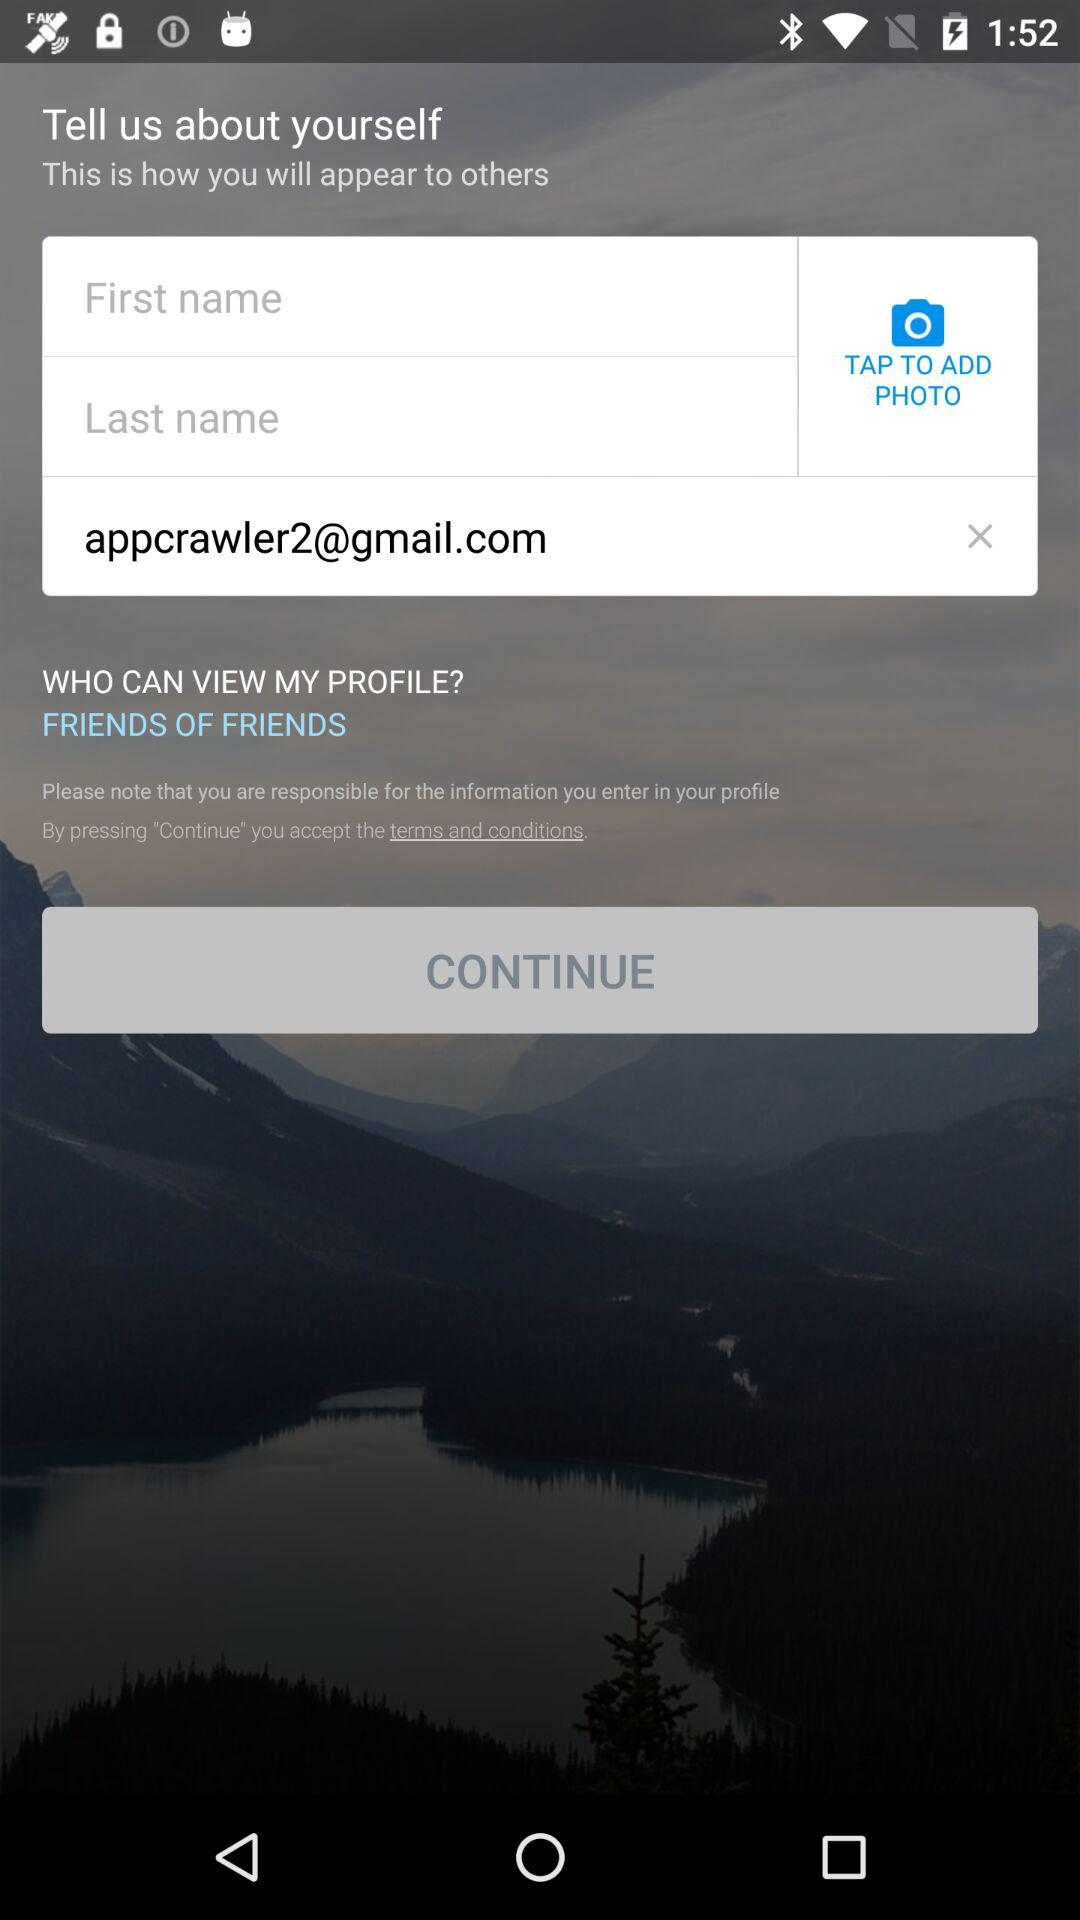How many text inputs are there for the user to fill out?
Answer the question using a single word or phrase. 2 